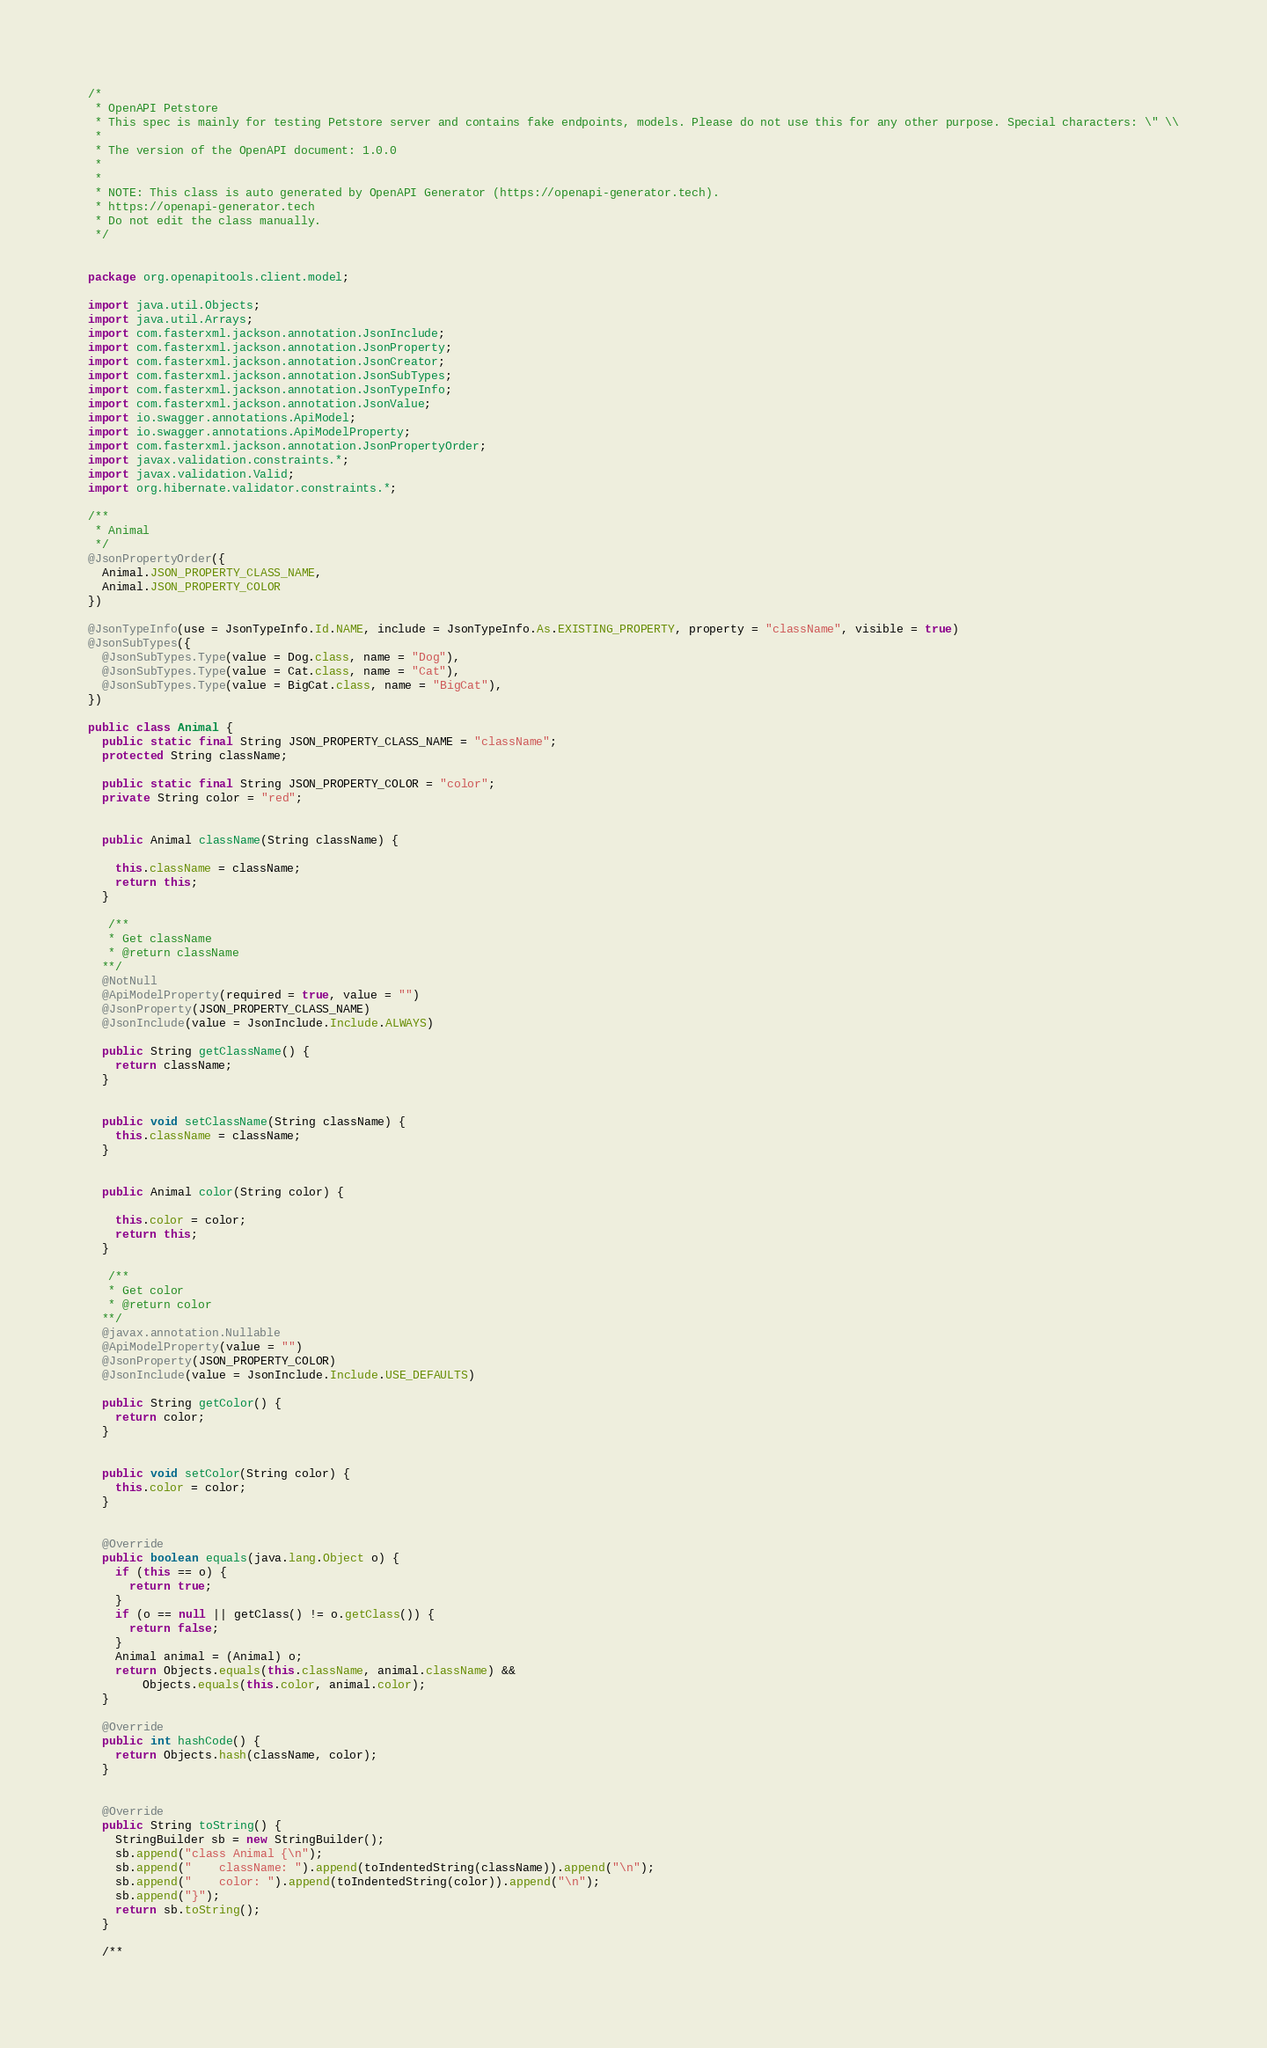<code> <loc_0><loc_0><loc_500><loc_500><_Java_>/*
 * OpenAPI Petstore
 * This spec is mainly for testing Petstore server and contains fake endpoints, models. Please do not use this for any other purpose. Special characters: \" \\
 *
 * The version of the OpenAPI document: 1.0.0
 * 
 *
 * NOTE: This class is auto generated by OpenAPI Generator (https://openapi-generator.tech).
 * https://openapi-generator.tech
 * Do not edit the class manually.
 */


package org.openapitools.client.model;

import java.util.Objects;
import java.util.Arrays;
import com.fasterxml.jackson.annotation.JsonInclude;
import com.fasterxml.jackson.annotation.JsonProperty;
import com.fasterxml.jackson.annotation.JsonCreator;
import com.fasterxml.jackson.annotation.JsonSubTypes;
import com.fasterxml.jackson.annotation.JsonTypeInfo;
import com.fasterxml.jackson.annotation.JsonValue;
import io.swagger.annotations.ApiModel;
import io.swagger.annotations.ApiModelProperty;
import com.fasterxml.jackson.annotation.JsonPropertyOrder;
import javax.validation.constraints.*;
import javax.validation.Valid;
import org.hibernate.validator.constraints.*;

/**
 * Animal
 */
@JsonPropertyOrder({
  Animal.JSON_PROPERTY_CLASS_NAME,
  Animal.JSON_PROPERTY_COLOR
})

@JsonTypeInfo(use = JsonTypeInfo.Id.NAME, include = JsonTypeInfo.As.EXISTING_PROPERTY, property = "className", visible = true)
@JsonSubTypes({
  @JsonSubTypes.Type(value = Dog.class, name = "Dog"),
  @JsonSubTypes.Type(value = Cat.class, name = "Cat"),
  @JsonSubTypes.Type(value = BigCat.class, name = "BigCat"),
})

public class Animal {
  public static final String JSON_PROPERTY_CLASS_NAME = "className";
  protected String className;

  public static final String JSON_PROPERTY_COLOR = "color";
  private String color = "red";


  public Animal className(String className) {
    
    this.className = className;
    return this;
  }

   /**
   * Get className
   * @return className
  **/
  @NotNull
  @ApiModelProperty(required = true, value = "")
  @JsonProperty(JSON_PROPERTY_CLASS_NAME)
  @JsonInclude(value = JsonInclude.Include.ALWAYS)

  public String getClassName() {
    return className;
  }


  public void setClassName(String className) {
    this.className = className;
  }


  public Animal color(String color) {
    
    this.color = color;
    return this;
  }

   /**
   * Get color
   * @return color
  **/
  @javax.annotation.Nullable
  @ApiModelProperty(value = "")
  @JsonProperty(JSON_PROPERTY_COLOR)
  @JsonInclude(value = JsonInclude.Include.USE_DEFAULTS)

  public String getColor() {
    return color;
  }


  public void setColor(String color) {
    this.color = color;
  }


  @Override
  public boolean equals(java.lang.Object o) {
    if (this == o) {
      return true;
    }
    if (o == null || getClass() != o.getClass()) {
      return false;
    }
    Animal animal = (Animal) o;
    return Objects.equals(this.className, animal.className) &&
        Objects.equals(this.color, animal.color);
  }

  @Override
  public int hashCode() {
    return Objects.hash(className, color);
  }


  @Override
  public String toString() {
    StringBuilder sb = new StringBuilder();
    sb.append("class Animal {\n");
    sb.append("    className: ").append(toIndentedString(className)).append("\n");
    sb.append("    color: ").append(toIndentedString(color)).append("\n");
    sb.append("}");
    return sb.toString();
  }

  /**</code> 